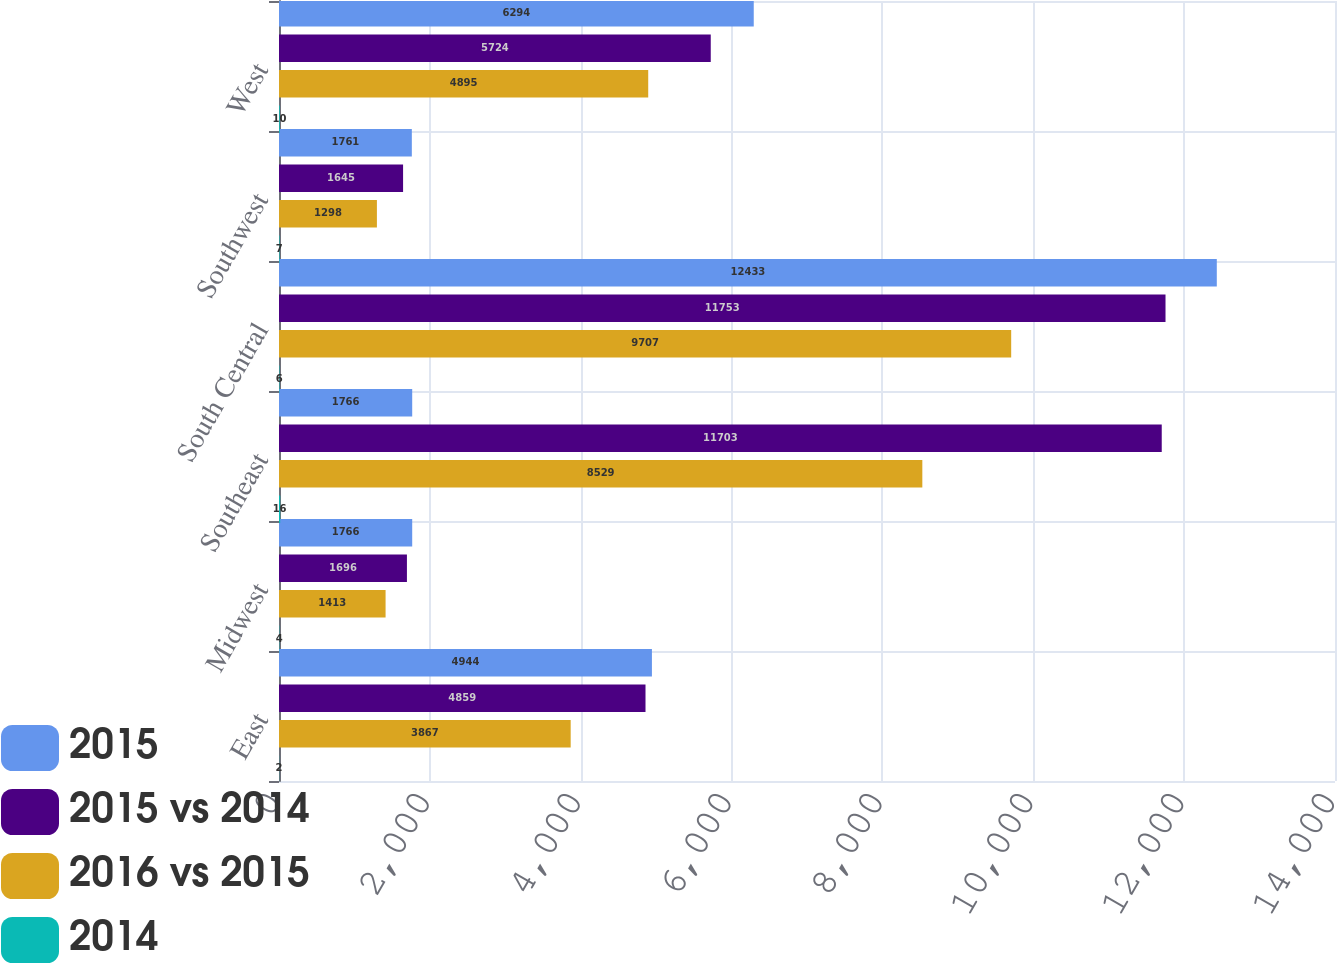<chart> <loc_0><loc_0><loc_500><loc_500><stacked_bar_chart><ecel><fcel>East<fcel>Midwest<fcel>Southeast<fcel>South Central<fcel>Southwest<fcel>West<nl><fcel>2015<fcel>4944<fcel>1766<fcel>1766<fcel>12433<fcel>1761<fcel>6294<nl><fcel>2015 vs 2014<fcel>4859<fcel>1696<fcel>11703<fcel>11753<fcel>1645<fcel>5724<nl><fcel>2016 vs 2015<fcel>3867<fcel>1413<fcel>8529<fcel>9707<fcel>1298<fcel>4895<nl><fcel>2014<fcel>2<fcel>4<fcel>16<fcel>6<fcel>7<fcel>10<nl></chart> 